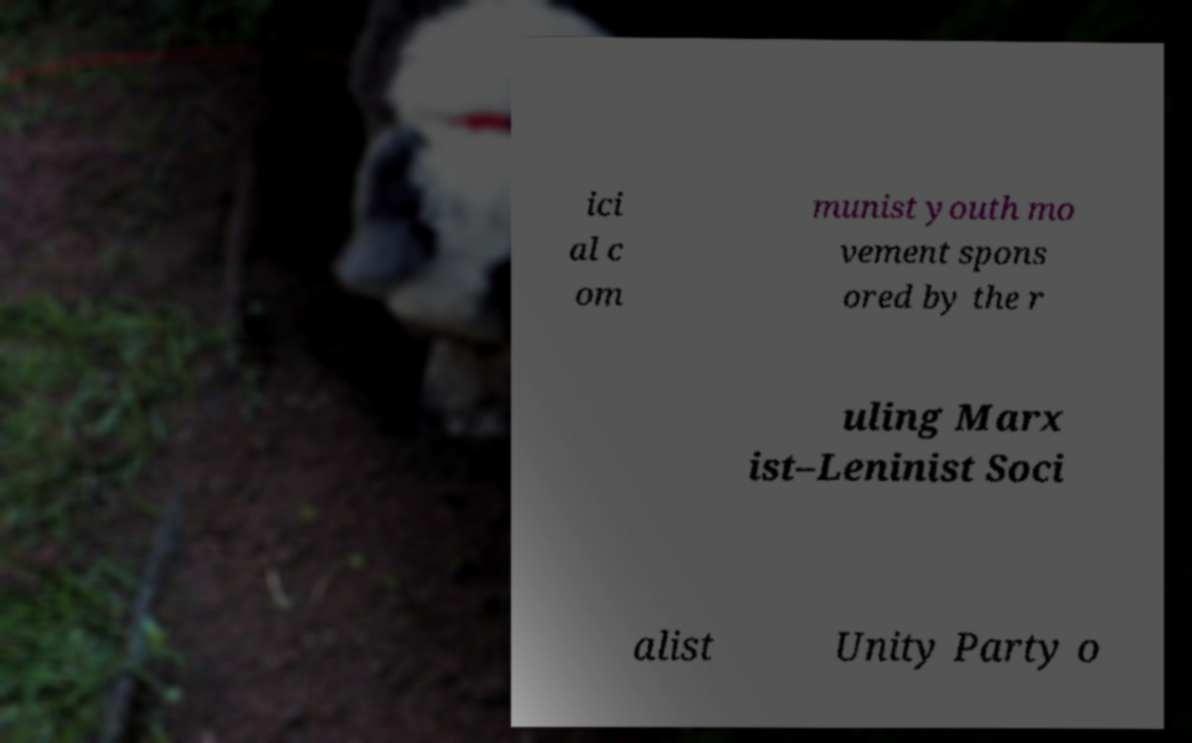What messages or text are displayed in this image? I need them in a readable, typed format. ici al c om munist youth mo vement spons ored by the r uling Marx ist–Leninist Soci alist Unity Party o 